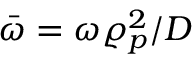Convert formula to latex. <formula><loc_0><loc_0><loc_500><loc_500>\bar { \omega } = \omega \varrho _ { p } ^ { 2 } / D</formula> 